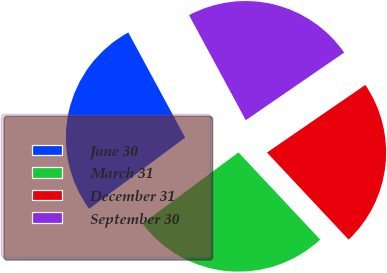Convert chart to OTSL. <chart><loc_0><loc_0><loc_500><loc_500><pie_chart><fcel>June 30<fcel>March 31<fcel>December 31<fcel>September 30<nl><fcel>27.28%<fcel>26.82%<fcel>22.6%<fcel>23.3%<nl></chart> 